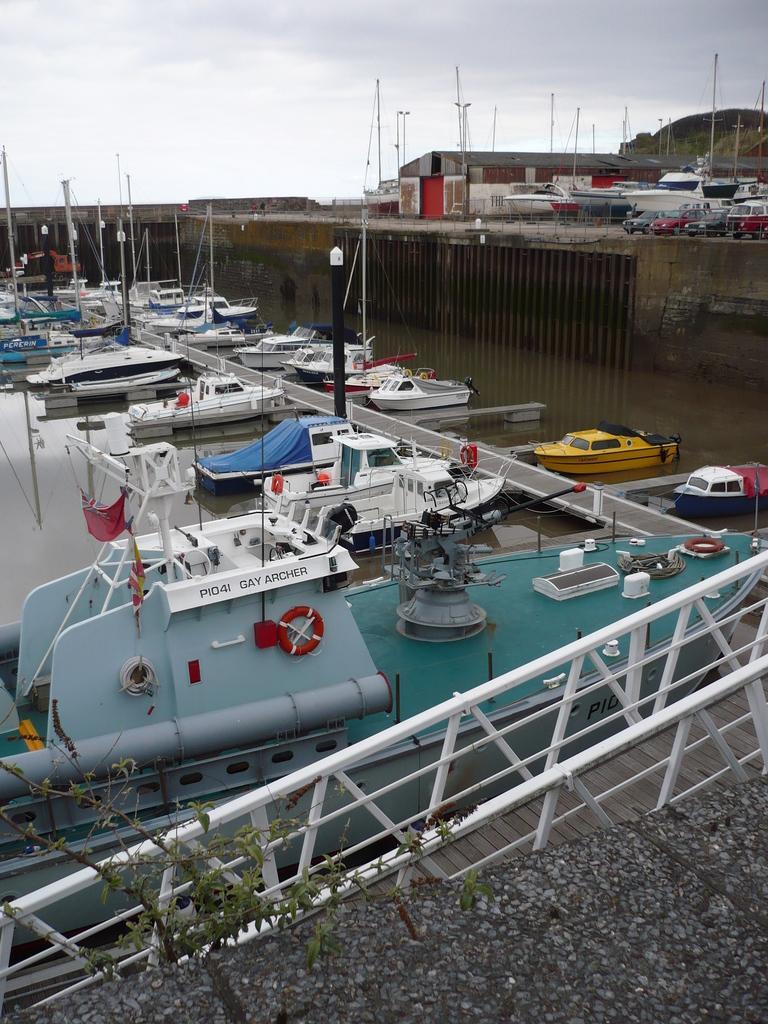Describe this image in one or two sentences. In the foreground of the image we can see a plant and road. In the middle of the image we can see some ships and some water body. On the top of the image we can see ships and the sky. 